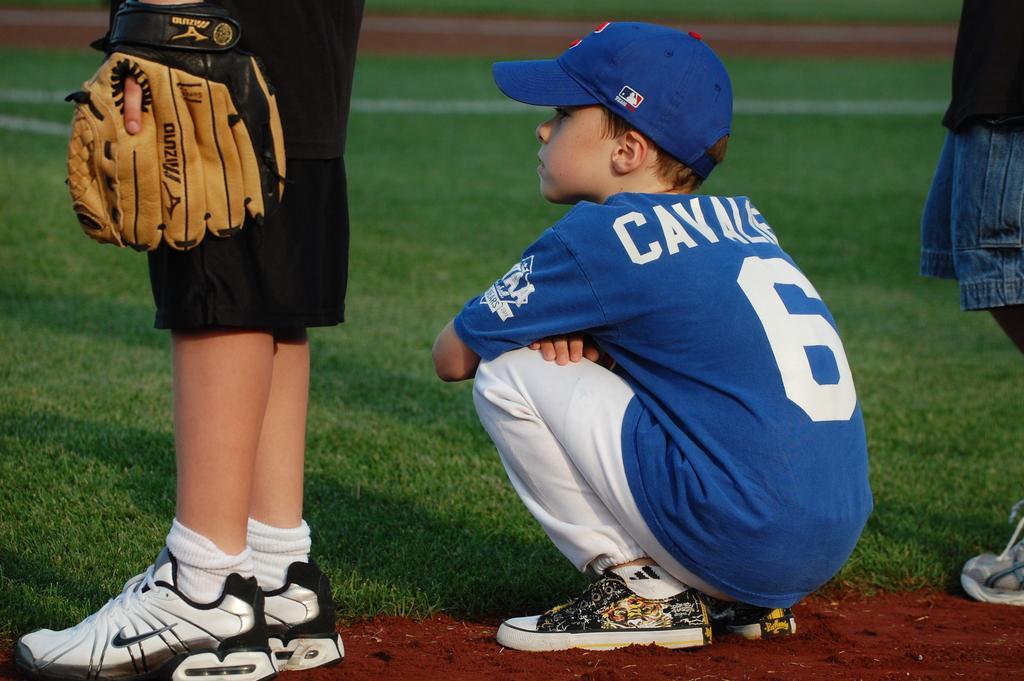Please provide a concise description of this image. This is a playing ground. Here I can see the green color grass. A boy is wearing blue color t-shirt, cap on the head and sitting on the ground facing towards the left side. Beside this boy I can see two persons are standing wearing white color shoes and gloves to the hands. 